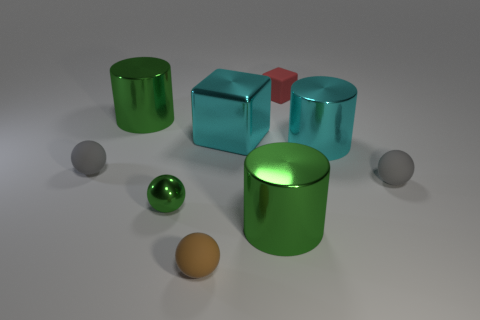There is a matte ball to the left of the small green shiny thing; what size is it?
Your answer should be very brief. Small. Is the size of the gray matte sphere that is to the left of the cyan metal cylinder the same as the red matte thing?
Keep it short and to the point. Yes. Is there any other thing that has the same color as the metallic cube?
Your answer should be very brief. Yes. There is a small brown thing; what shape is it?
Ensure brevity in your answer.  Sphere. How many metallic things are on the left side of the small red matte object and on the right side of the cyan cube?
Make the answer very short. 1. There is another brown object that is the same shape as the tiny metal object; what is it made of?
Offer a very short reply. Rubber. Are there the same number of red blocks that are behind the red cube and red things behind the big block?
Provide a short and direct response. No. Do the small cube and the big cyan cube have the same material?
Provide a succinct answer. No. What number of cyan objects are either large shiny things or large blocks?
Offer a very short reply. 2. What number of tiny brown matte objects have the same shape as the red rubber thing?
Your answer should be compact. 0. 